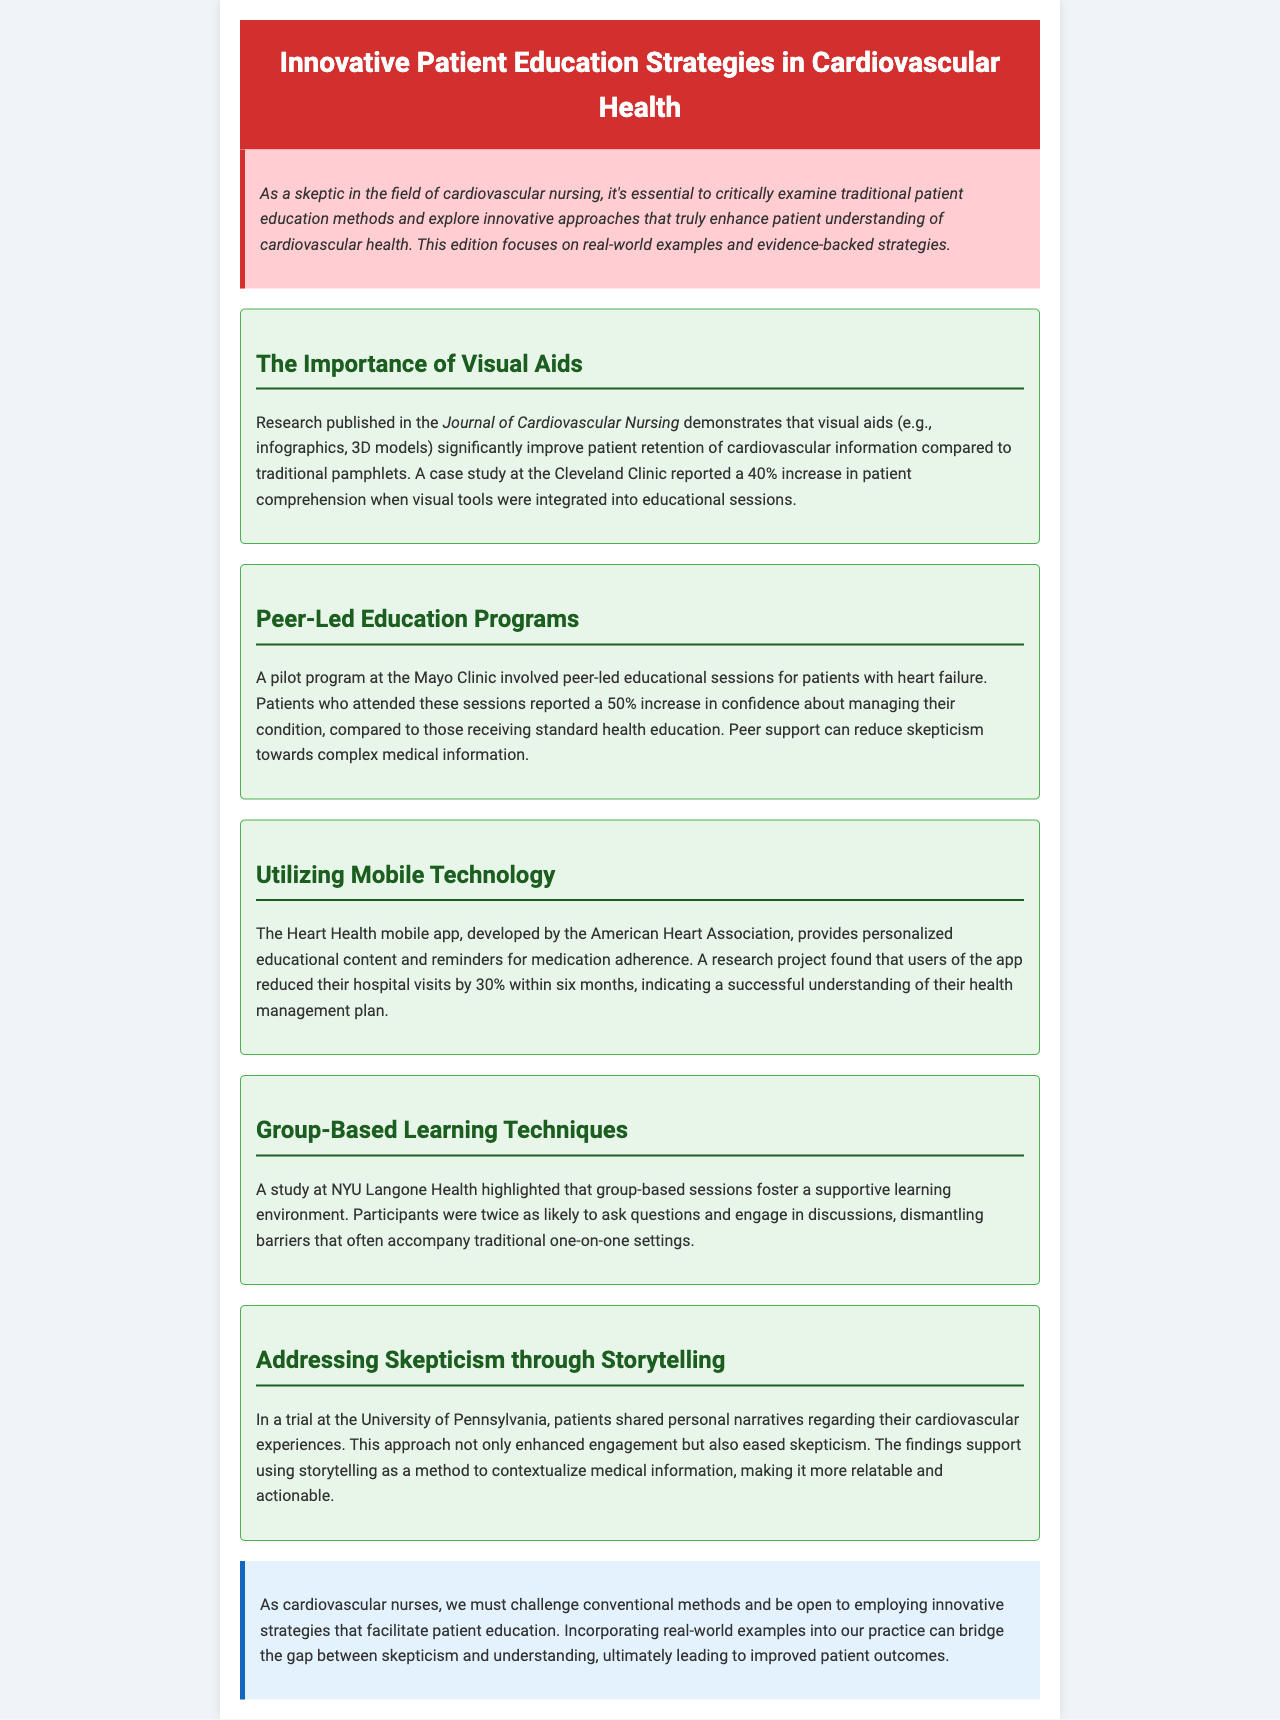what is the title of the newsletter? The title of the newsletter is provided in the header section of the document.
Answer: Innovative Patient Education Strategies in Cardiovascular Health which journal published research on visual aids? The document mentions a specific journal that published research supporting the use of visual aids in patient education.
Answer: Journal of Cardiovascular Nursing what was the percentage increase in patient comprehension at the Cleveland Clinic? The key point about visual aids includes a statistic regarding increased comprehension from a specific case study.
Answer: 40% how much did hospital visits reduce by using the Heart Health mobile app? The document quantifies the reduction in hospital visits for users of the mobile app based on research findings.
Answer: 30% what method does the University of Pennsylvania use to address skepticism? The document suggests a specific innovative approach utilized in a trial to tackle patient skepticism about medical information.
Answer: Storytelling what type of education programs were piloted at the Mayo Clinic? The document identifies the format of educational sessions that were part of a pilot program at a notable health facility.
Answer: Peer-led education how likely were participants to ask questions in group-based sessions according to the NYU Langone Health study? The document summarizes the results of a study, indicating the likelihood of participants engaging with questions during sessions.
Answer: Twice as likely 